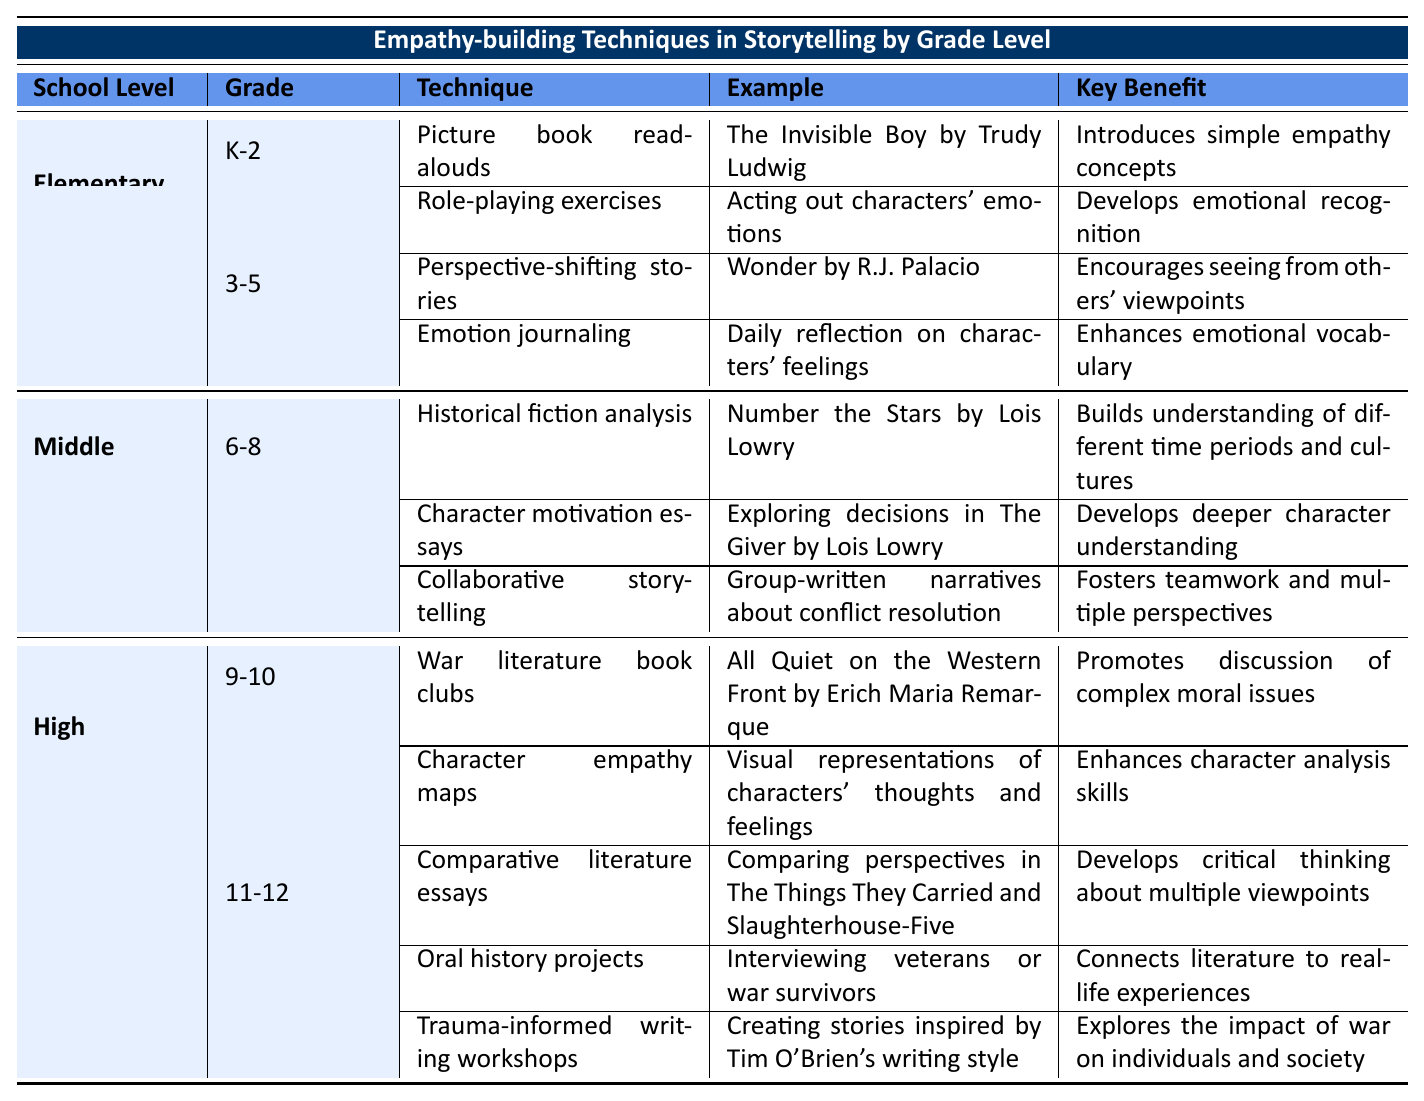What empathy-building technique is used for grades 3-5? The table shows that for grades 3-5, the empathy-building techniques are "Perspective-shifting stories" and "Emotion journaling".
Answer: Perspective-shifting stories, Emotion journaling What is the example used for the technique 'Historical fiction analysis'? The table states that the example for the technique 'Historical fiction analysis' is "Number the Stars by Lois Lowry".
Answer: Number the Stars by Lois Lowry Is "Emotion journaling" listed as a technique for grades K-2? The table indicates that "Emotion journaling" is not listed under K-2; it is associated with grades 3-5.
Answer: No How many techniques are listed for middle school grades? The table indicates that there are three techniques listed for middle school grades 6-8: "Historical fiction analysis", "Character motivation essays", and "Collaborative storytelling". Therefore, the total is 3.
Answer: 3 What is the key benefit of “War literature book clubs”? According to the table, the key benefit of "War literature book clubs" is "Promotes discussion of complex moral issues".
Answer: Promotes discussion of complex moral issues Which elementary grades utilize role-playing exercises? In the table, "Role-playing exercises" are listed under grades K-2 for elementary school, indicating that these grades utilize this technique.
Answer: Grades K-2 What is the total number of techniques listed for high school grades 11-12? The table shows that there are three techniques listed for high school grades 11-12: "Comparative literature essays", "Oral history projects", and "Trauma-informed writing workshops". Thus, the total is 3.
Answer: 3 How does "Character motivation essays" benefit students? The table states that "Character motivation essays" benefit students by developing a deeper character understanding.
Answer: Develops deeper character understanding Compare the number of techniques listed for elementary school and middle school. The table lists four techniques for elementary school (2 for K-2 and 2 for 3-5) and three techniques for middle school (all under grades 6-8). Thus, elementary school has one more technique than middle school.
Answer: Elementary school has one more technique What empathetic storytelling technique involves interviewing individuals? The table states that the technique involving interviewing individuals is "Oral history projects".
Answer: Oral history projects What are the key benefits of the technique "Trauma-informed writing workshops"? The table indicates that the key benefit of "Trauma-informed writing workshops" is that it explores the impact of war on individuals and society.
Answer: Explores the impact of war on individuals and society 